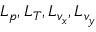Convert formula to latex. <formula><loc_0><loc_0><loc_500><loc_500>L _ { p } , L _ { T } , L _ { v _ { x } } , L _ { v _ { y } }</formula> 